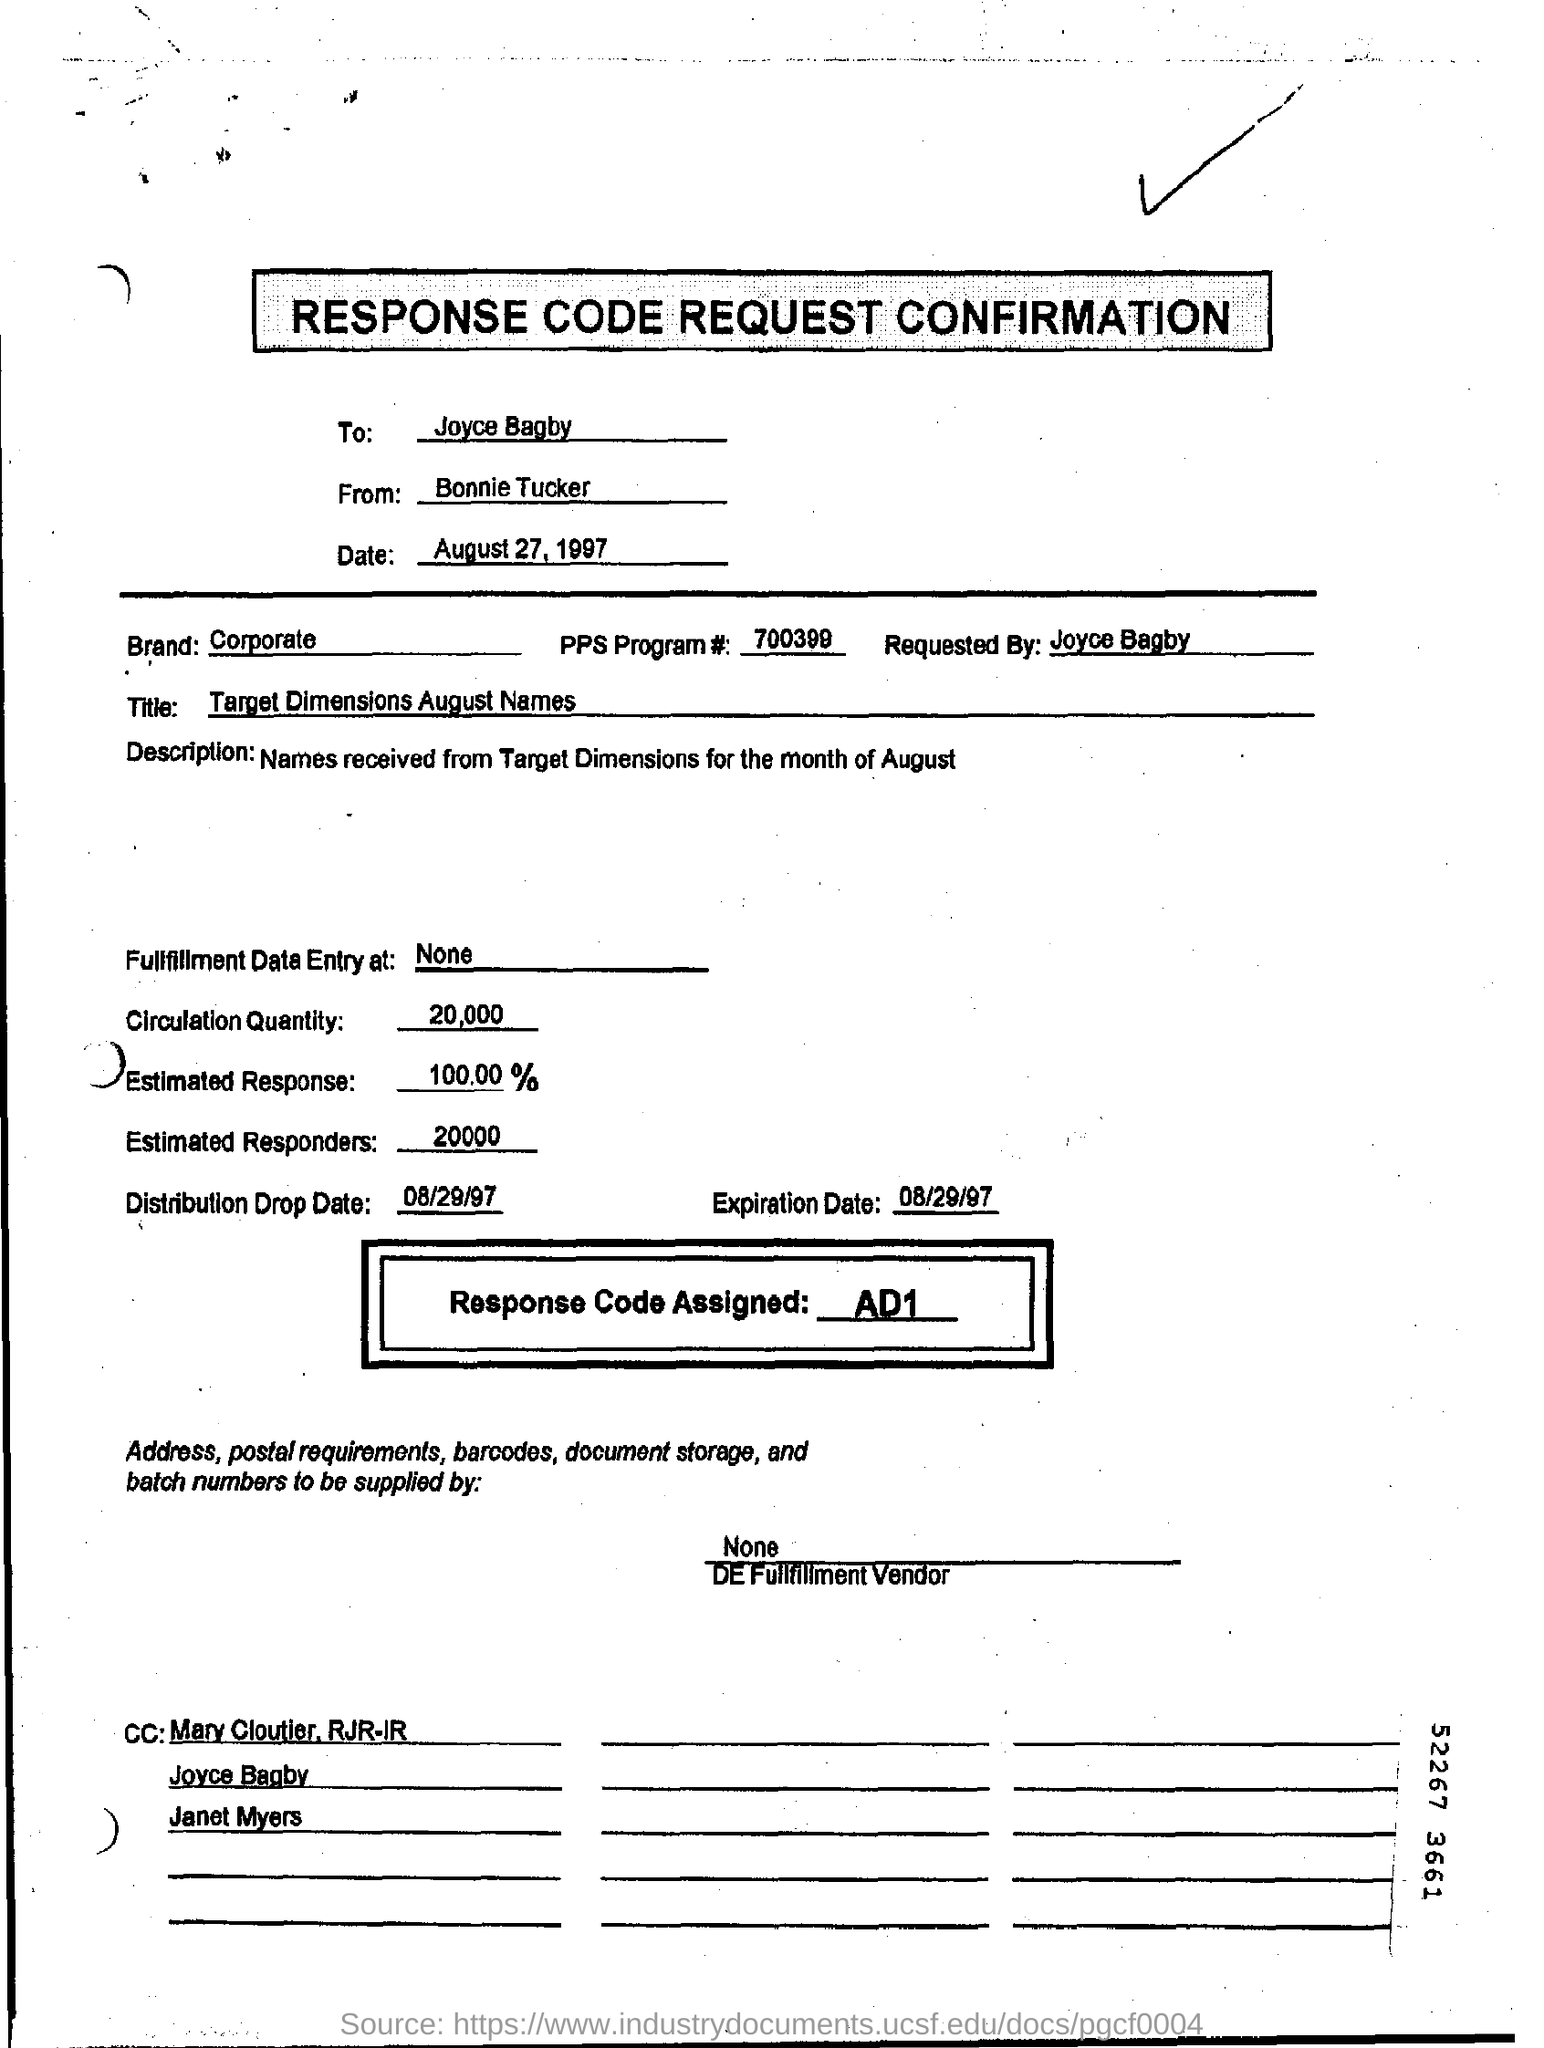Who is requesting the response code confirmation?
Your answer should be compact. Joyce Bagby. How much is the circulation quantity?
Offer a very short reply. 20,000. What is the assigned response code?
Ensure brevity in your answer.  AD1. What is the number of the PPS program?
Your answer should be compact. 700399. What value is entered in the "Brand" field?
Your answer should be compact. Corporate. 